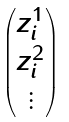<formula> <loc_0><loc_0><loc_500><loc_500>\begin{pmatrix} z _ { i } ^ { 1 } \\ z _ { i } ^ { 2 } \\ \vdots \end{pmatrix}</formula> 